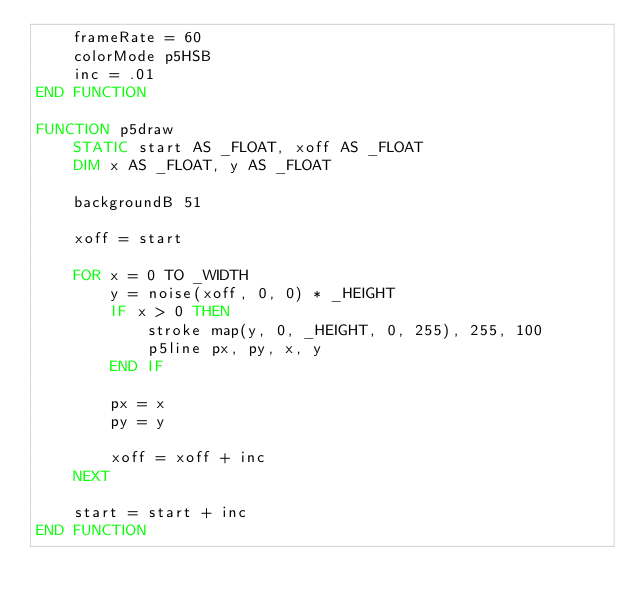<code> <loc_0><loc_0><loc_500><loc_500><_VisualBasic_>    frameRate = 60
    colorMode p5HSB
    inc = .01
END FUNCTION

FUNCTION p5draw
    STATIC start AS _FLOAT, xoff AS _FLOAT
    DIM x AS _FLOAT, y AS _FLOAT

    backgroundB 51

    xoff = start

    FOR x = 0 TO _WIDTH
        y = noise(xoff, 0, 0) * _HEIGHT
        IF x > 0 THEN
            stroke map(y, 0, _HEIGHT, 0, 255), 255, 100
            p5line px, py, x, y
        END IF

        px = x
        py = y

        xoff = xoff + inc
    NEXT

    start = start + inc
END FUNCTION
</code> 